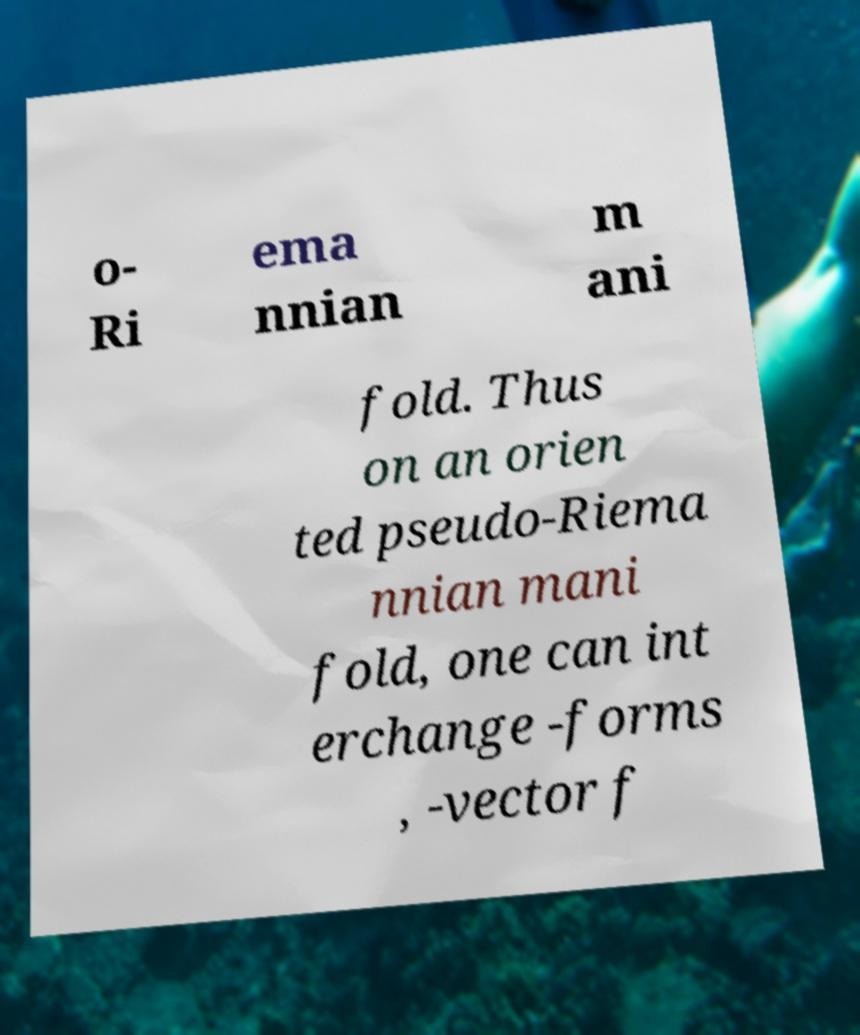There's text embedded in this image that I need extracted. Can you transcribe it verbatim? o- Ri ema nnian m ani fold. Thus on an orien ted pseudo-Riema nnian mani fold, one can int erchange -forms , -vector f 